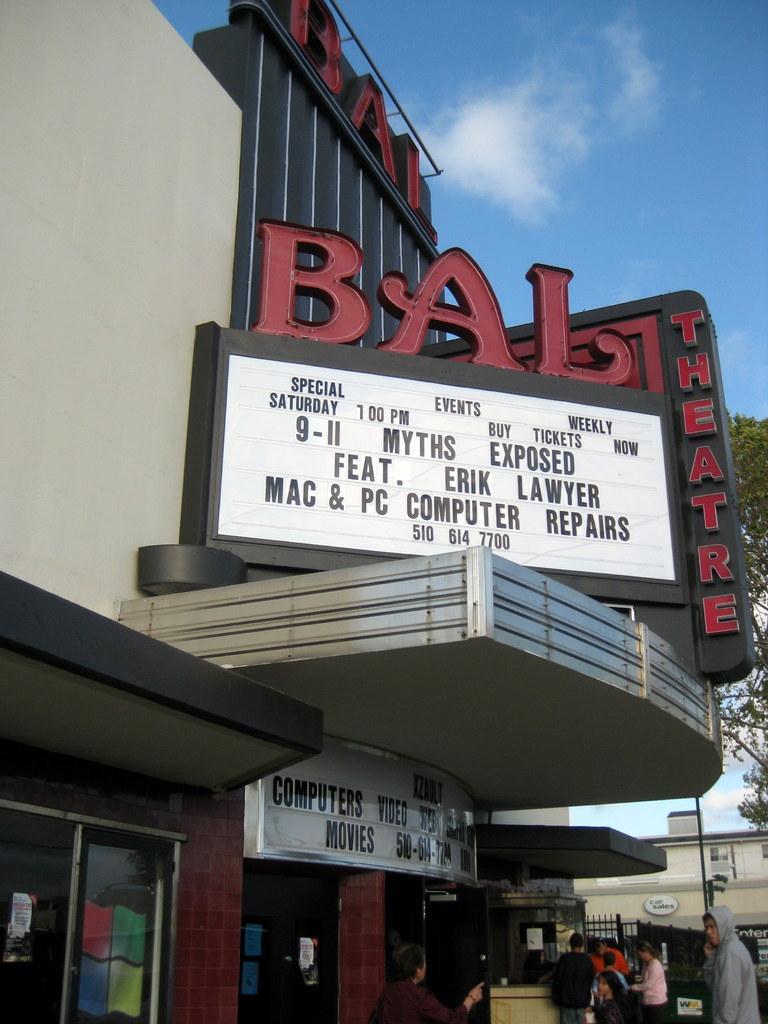Describe this image in one or two sentences. This is the picture of a building. In this image there are group of people standing. There is a text on the building and there is a board on the building and there is a text on the board. At the back there is a building, pole and there is a tree. At the top there is sky and there are clouds. 